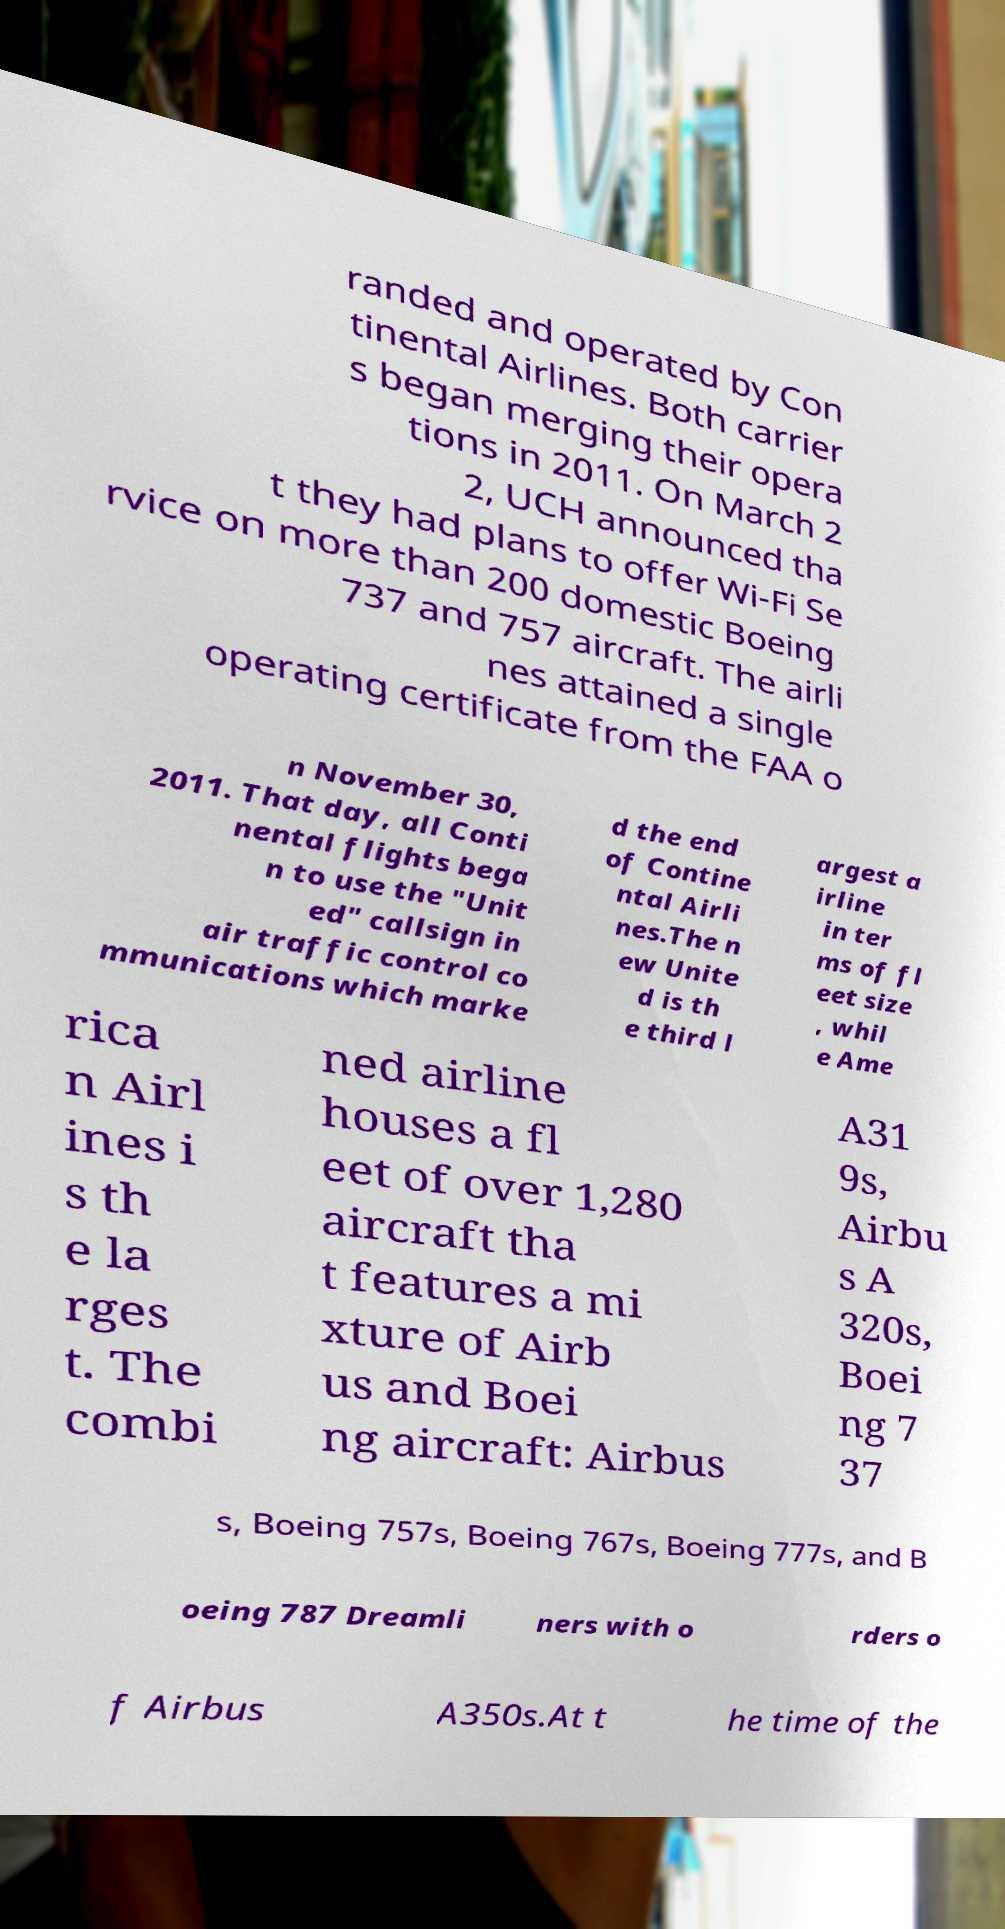Can you read and provide the text displayed in the image?This photo seems to have some interesting text. Can you extract and type it out for me? randed and operated by Con tinental Airlines. Both carrier s began merging their opera tions in 2011. On March 2 2, UCH announced tha t they had plans to offer Wi-Fi Se rvice on more than 200 domestic Boeing 737 and 757 aircraft. The airli nes attained a single operating certificate from the FAA o n November 30, 2011. That day, all Conti nental flights bega n to use the "Unit ed" callsign in air traffic control co mmunications which marke d the end of Contine ntal Airli nes.The n ew Unite d is th e third l argest a irline in ter ms of fl eet size , whil e Ame rica n Airl ines i s th e la rges t. The combi ned airline houses a fl eet of over 1,280 aircraft tha t features a mi xture of Airb us and Boei ng aircraft: Airbus A31 9s, Airbu s A 320s, Boei ng 7 37 s, Boeing 757s, Boeing 767s, Boeing 777s, and B oeing 787 Dreamli ners with o rders o f Airbus A350s.At t he time of the 